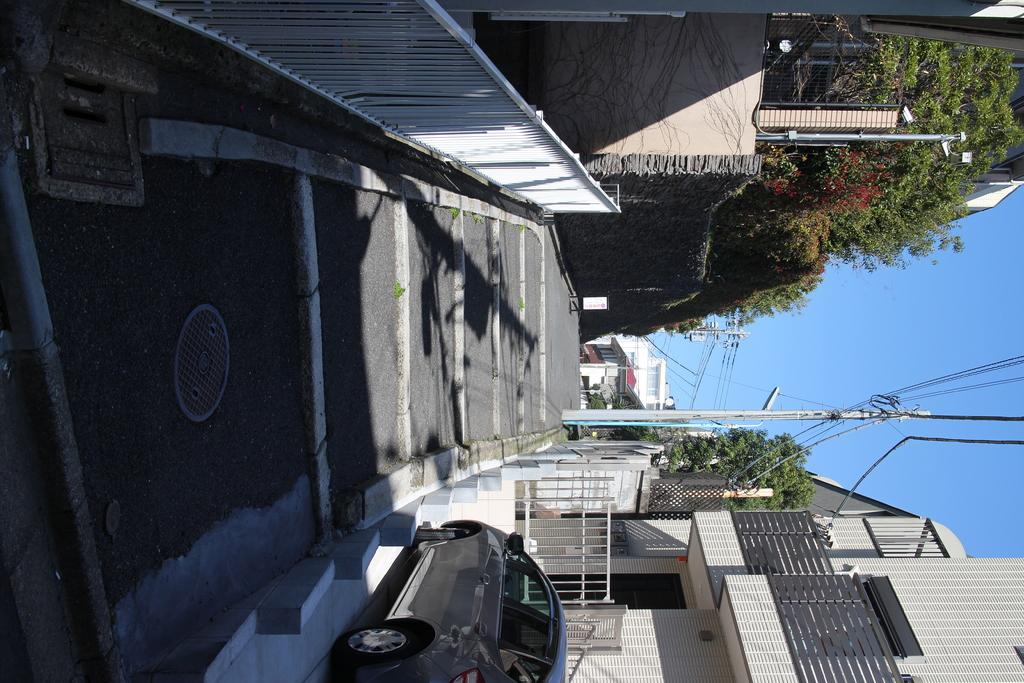What is the main feature of the image? There is a road in the image. What can be seen on either side of the road? There are buildings on both sides of the road. What type of vehicle is visible in the image? A car is present at the bottom of the image. What natural elements are present in the image? There are trees in the image. What man-made structures can be seen in the image besides the buildings? There is a pole with wires in the image. How many cows are grazing on the side of the road in the image? There are no cows present in the image. What change occurs in the image when you look at it from a different angle? The image does not change when viewed from different angles, as it is a static image. 